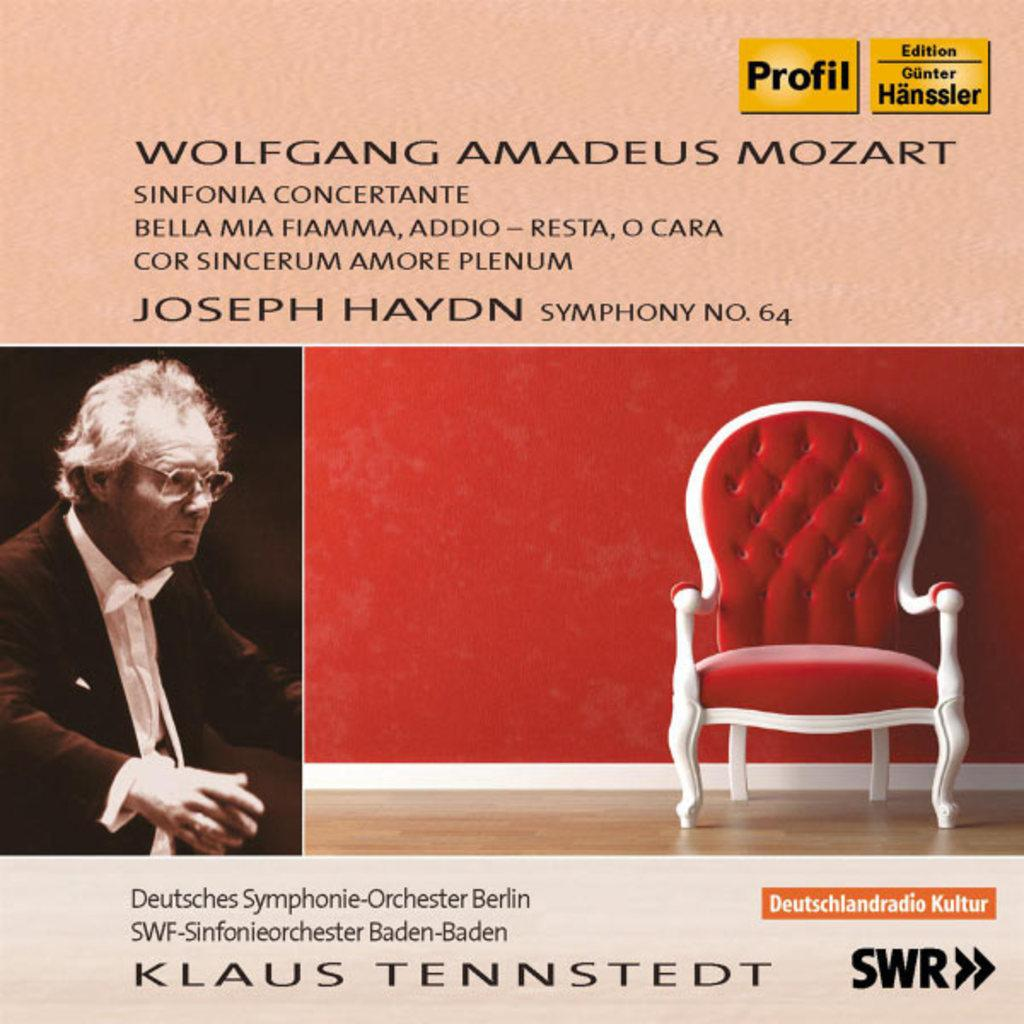What is located on the left side of the image? There is a man on the left side of the image. What is on the right side of the image? There is a chair, a wall, and a floor on the right side of the image. Can you describe the text in the image? There is some text at the top and bottom of the image. What type of drain is visible in the image? There is no drain present in the image. What color is the yarn used to decorate the wall in the image? There is no yarn present in the image. 